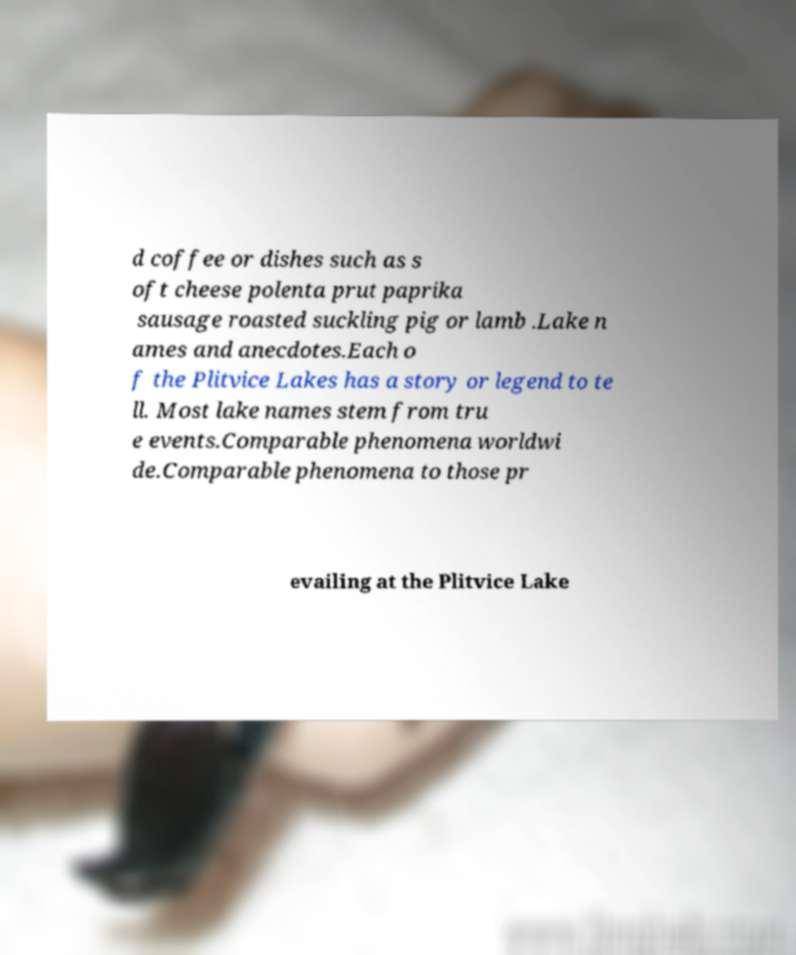Please identify and transcribe the text found in this image. d coffee or dishes such as s oft cheese polenta prut paprika sausage roasted suckling pig or lamb .Lake n ames and anecdotes.Each o f the Plitvice Lakes has a story or legend to te ll. Most lake names stem from tru e events.Comparable phenomena worldwi de.Comparable phenomena to those pr evailing at the Plitvice Lake 